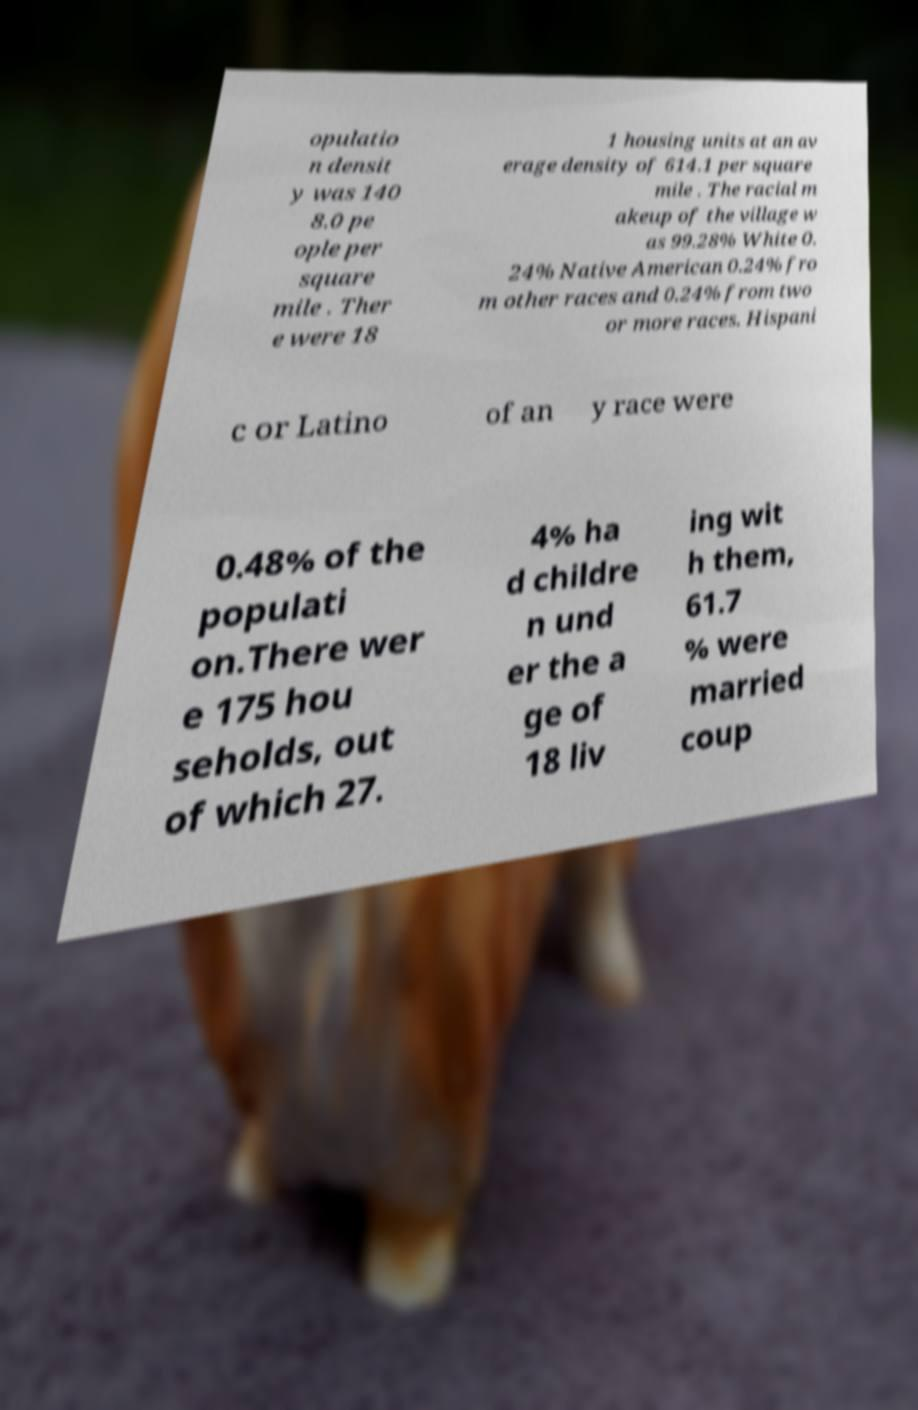What messages or text are displayed in this image? I need them in a readable, typed format. opulatio n densit y was 140 8.0 pe ople per square mile . Ther e were 18 1 housing units at an av erage density of 614.1 per square mile . The racial m akeup of the village w as 99.28% White 0. 24% Native American 0.24% fro m other races and 0.24% from two or more races. Hispani c or Latino of an y race were 0.48% of the populati on.There wer e 175 hou seholds, out of which 27. 4% ha d childre n und er the a ge of 18 liv ing wit h them, 61.7 % were married coup 